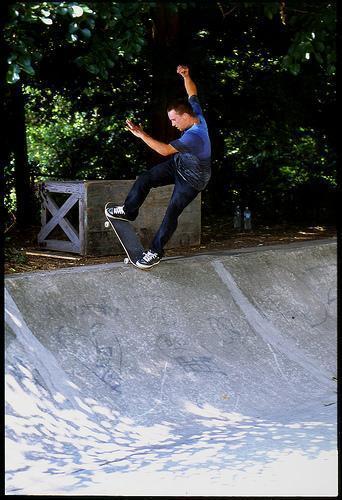How many skateboards are in the photo?
Give a very brief answer. 1. 